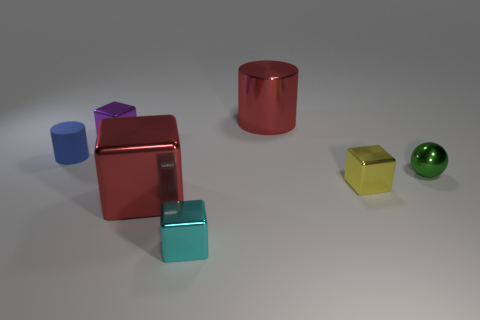Add 3 big cyan balls. How many objects exist? 10 Subtract all cylinders. How many objects are left? 5 Subtract all big green rubber things. Subtract all tiny blue rubber things. How many objects are left? 6 Add 5 green objects. How many green objects are left? 6 Add 1 green balls. How many green balls exist? 2 Subtract 1 green spheres. How many objects are left? 6 